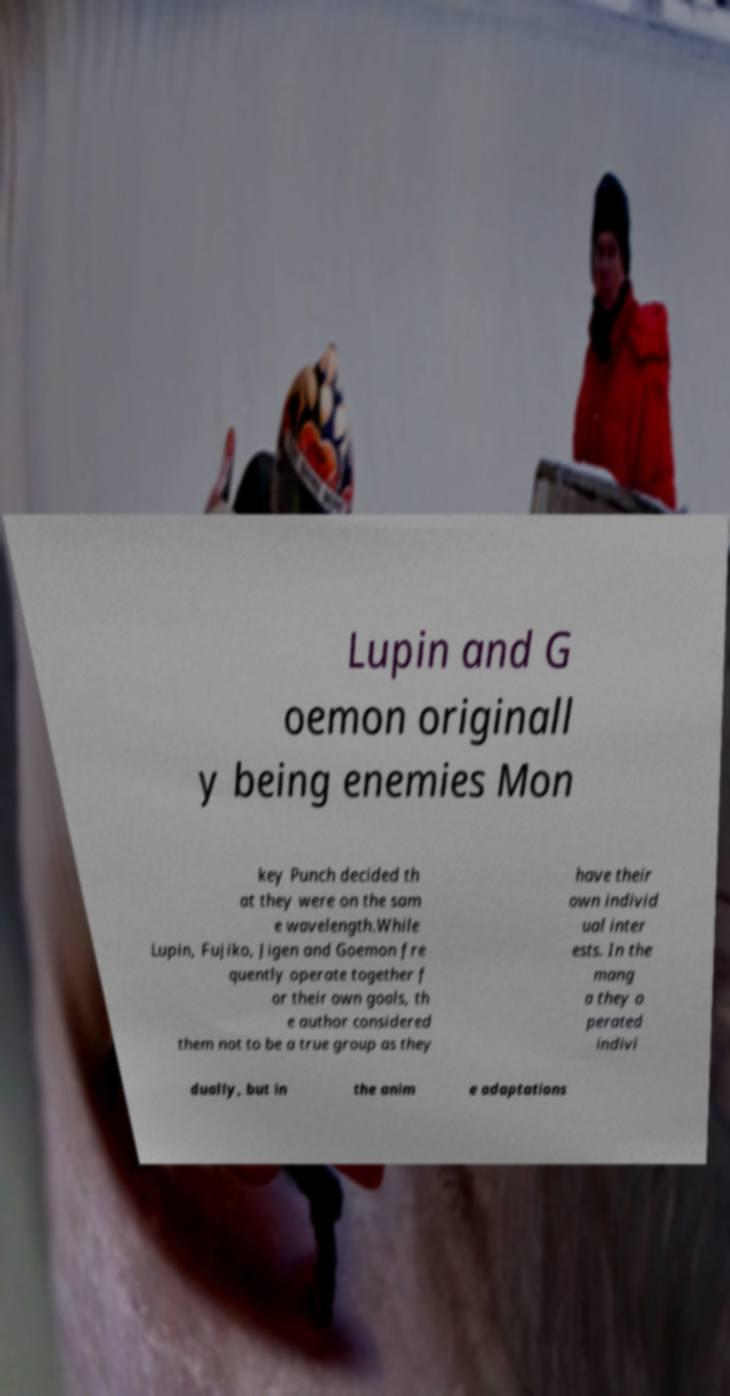Could you assist in decoding the text presented in this image and type it out clearly? Lupin and G oemon originall y being enemies Mon key Punch decided th at they were on the sam e wavelength.While Lupin, Fujiko, Jigen and Goemon fre quently operate together f or their own goals, th e author considered them not to be a true group as they have their own individ ual inter ests. In the mang a they o perated indivi dually, but in the anim e adaptations 